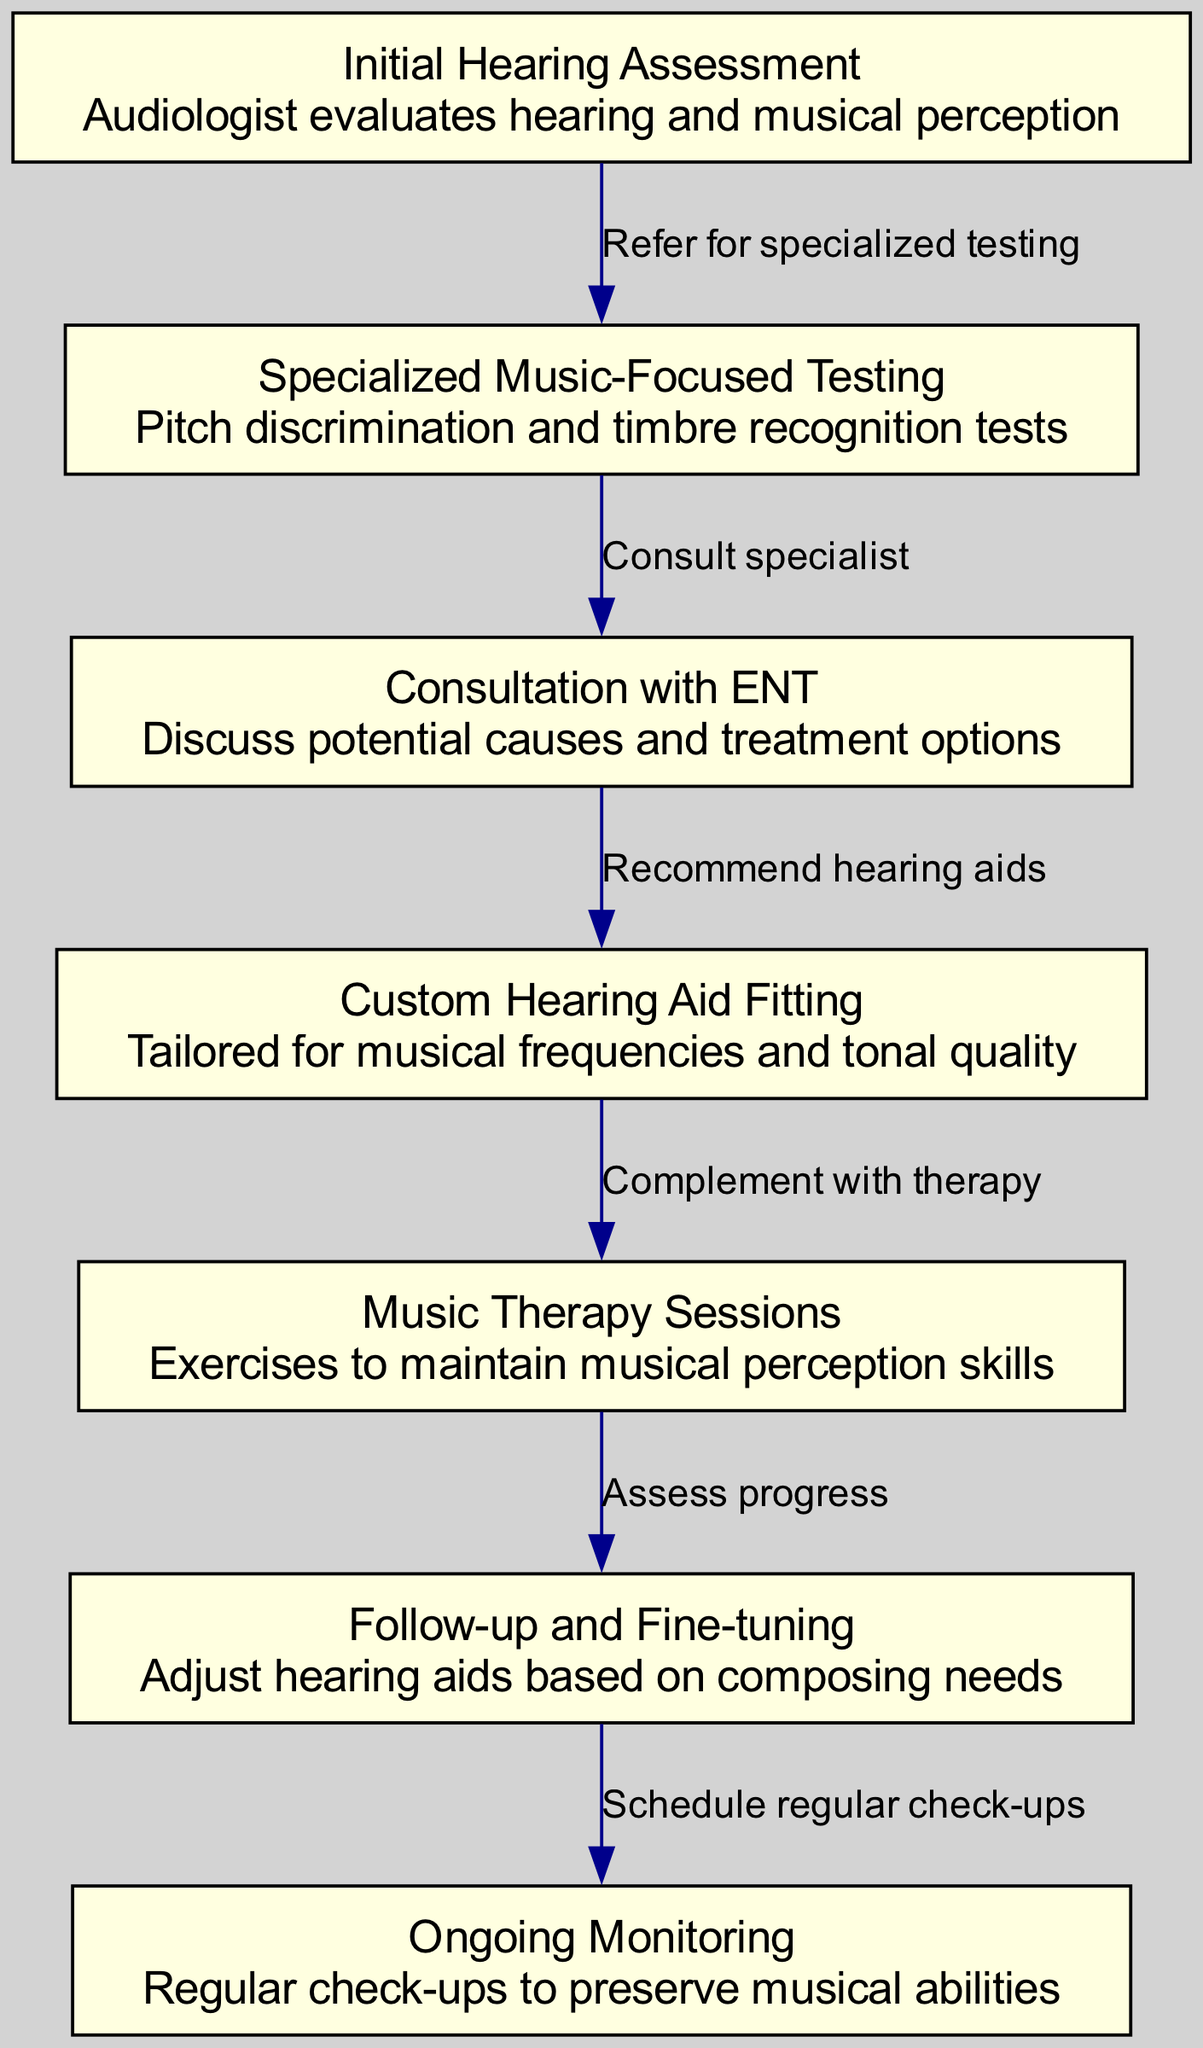What is the first step in the patient journey? The diagram indicates that the first step is the "Initial Hearing Assessment," where the audiologist evaluates hearing and musical perception.
Answer: Initial Hearing Assessment How many nodes are included in the diagram? By counting the distinct nodes listed in the diagram, there are a total of 7 nodes.
Answer: 7 What type of testing follows the initial hearing assessment? The diagram shows that "Specialized Music-Focused Testing" follows the initial hearing assessment, as indicated by the connection from node 1 to node 2.
Answer: Specialized Music-Focused Testing What is the primary focus of the custom hearing aid fitting? The description for "Custom Hearing Aid Fitting" states that it is tailored for musical frequencies and tonal quality, emphasizing the importance of musical characteristics in the fitting.
Answer: Musical frequencies and tonal quality What happens after the music therapy sessions? After "Music Therapy Sessions," the next step is "Follow-up and Fine-tuning," which assesses the progress and adjusts hearing aids accordingly.
Answer: Follow-up and Fine-tuning What is the final step in the patient journey? The last step in the patient journey as indicated in the diagram is "Ongoing Monitoring," which involves regular check-ups to preserve musical abilities.
Answer: Ongoing Monitoring Which node involves discussing potential causes and treatment options? The node labeled "Consultation with ENT" is specifically focused on discussing potential causes and treatment options related to hearing loss.
Answer: Consultation with ENT How many edges connect the nodes in the diagram? By examining the relationships depicted in the diagram, there are a total of 6 edges connecting all the nodes.
Answer: 6 